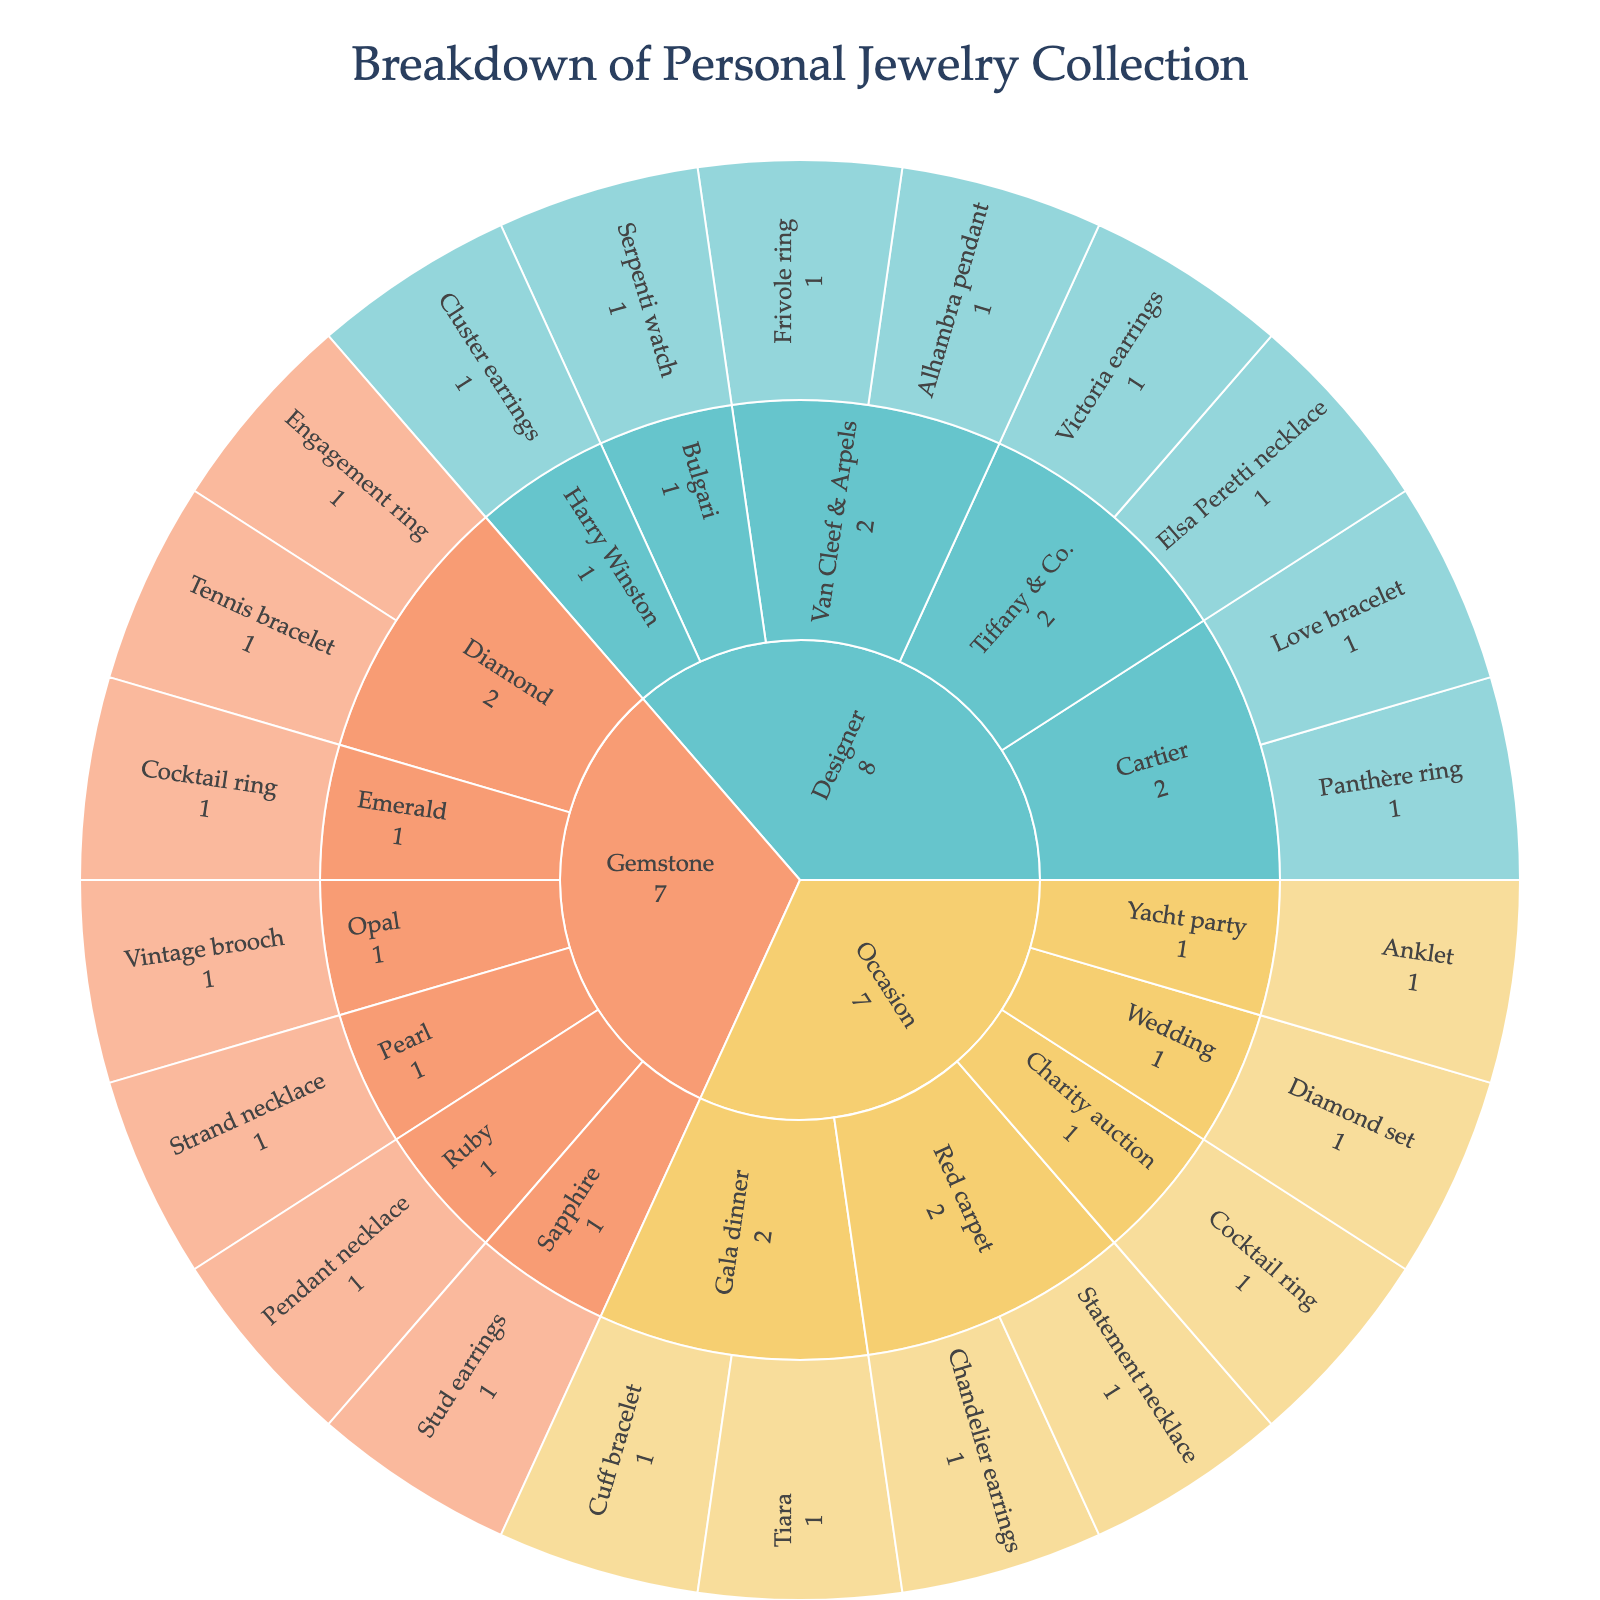What's the title of the plot? The title is usually placed at the top of the plot and is used to describe the main topic of the visualization.
Answer: Breakdown of Personal Jewelry Collection What are the categories represented in the sunburst plot? The first hierarchical level in the plot shows the main categories.
Answer: Designer, Gemstone, Occasion Which designer category has the most items? To answer this, one needs to view the sections labeled under the Designer category and count or visually estimate the items.
Answer: Cartier and Van Cleef & Arpels (tied) How many total items are under the Gemstone category? Sum up all the items listed under the Gemstone category.
Answer: 7 Which gemstone has the fewest items? Check each section under the Gemstone category and identify the one with the least division.
Answer: Pearl and Opal (tied) Are there more items in the Designer category or the Occasion category? Compare the total number of items under each of these categories.
Answer: Designer Which occasion has the most unique items? Look at the sections within the Occasion category and compare the number of unique items.
Answer: Red carpet What's the total number of jewelry items in the collection? Sum up all the values shown in the plot.
Answer: 24 Which category includes the "Vintage brooch"? Trace the path starting from the outermost part of the sunburst inward to find which main category it belongs to.
Answer: Gemstone Do more items belong to the "Red carpet" or the "Gala dinner" occasions? Compare the items under both occasions within the Occasion category.
Answer: Red carpet 